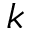<formula> <loc_0><loc_0><loc_500><loc_500>k</formula> 